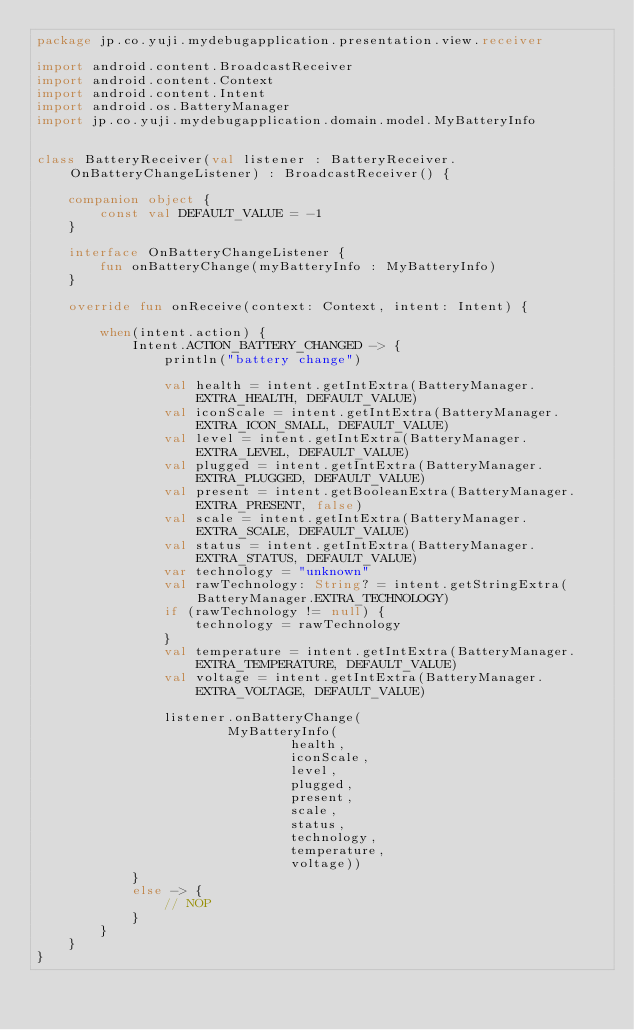Convert code to text. <code><loc_0><loc_0><loc_500><loc_500><_Kotlin_>package jp.co.yuji.mydebugapplication.presentation.view.receiver

import android.content.BroadcastReceiver
import android.content.Context
import android.content.Intent
import android.os.BatteryManager
import jp.co.yuji.mydebugapplication.domain.model.MyBatteryInfo


class BatteryReceiver(val listener : BatteryReceiver.OnBatteryChangeListener) : BroadcastReceiver() {

    companion object {
        const val DEFAULT_VALUE = -1
    }

    interface OnBatteryChangeListener {
        fun onBatteryChange(myBatteryInfo : MyBatteryInfo)
    }

    override fun onReceive(context: Context, intent: Intent) {

        when(intent.action) {
            Intent.ACTION_BATTERY_CHANGED -> {
                println("battery change")

                val health = intent.getIntExtra(BatteryManager.EXTRA_HEALTH, DEFAULT_VALUE)
                val iconScale = intent.getIntExtra(BatteryManager.EXTRA_ICON_SMALL, DEFAULT_VALUE)
                val level = intent.getIntExtra(BatteryManager.EXTRA_LEVEL, DEFAULT_VALUE)
                val plugged = intent.getIntExtra(BatteryManager.EXTRA_PLUGGED, DEFAULT_VALUE)
                val present = intent.getBooleanExtra(BatteryManager.EXTRA_PRESENT, false)
                val scale = intent.getIntExtra(BatteryManager.EXTRA_SCALE, DEFAULT_VALUE)
                val status = intent.getIntExtra(BatteryManager.EXTRA_STATUS, DEFAULT_VALUE)
                var technology = "unknown"
                val rawTechnology: String? = intent.getStringExtra(BatteryManager.EXTRA_TECHNOLOGY)
                if (rawTechnology != null) {
                    technology = rawTechnology
                }
                val temperature = intent.getIntExtra(BatteryManager.EXTRA_TEMPERATURE, DEFAULT_VALUE)
                val voltage = intent.getIntExtra(BatteryManager.EXTRA_VOLTAGE, DEFAULT_VALUE)

                listener.onBatteryChange(
                        MyBatteryInfo(
                                health,
                                iconScale,
                                level,
                                plugged,
                                present,
                                scale,
                                status,
                                technology,
                                temperature,
                                voltage))
            }
            else -> {
                // NOP
            }
        }
    }
}</code> 